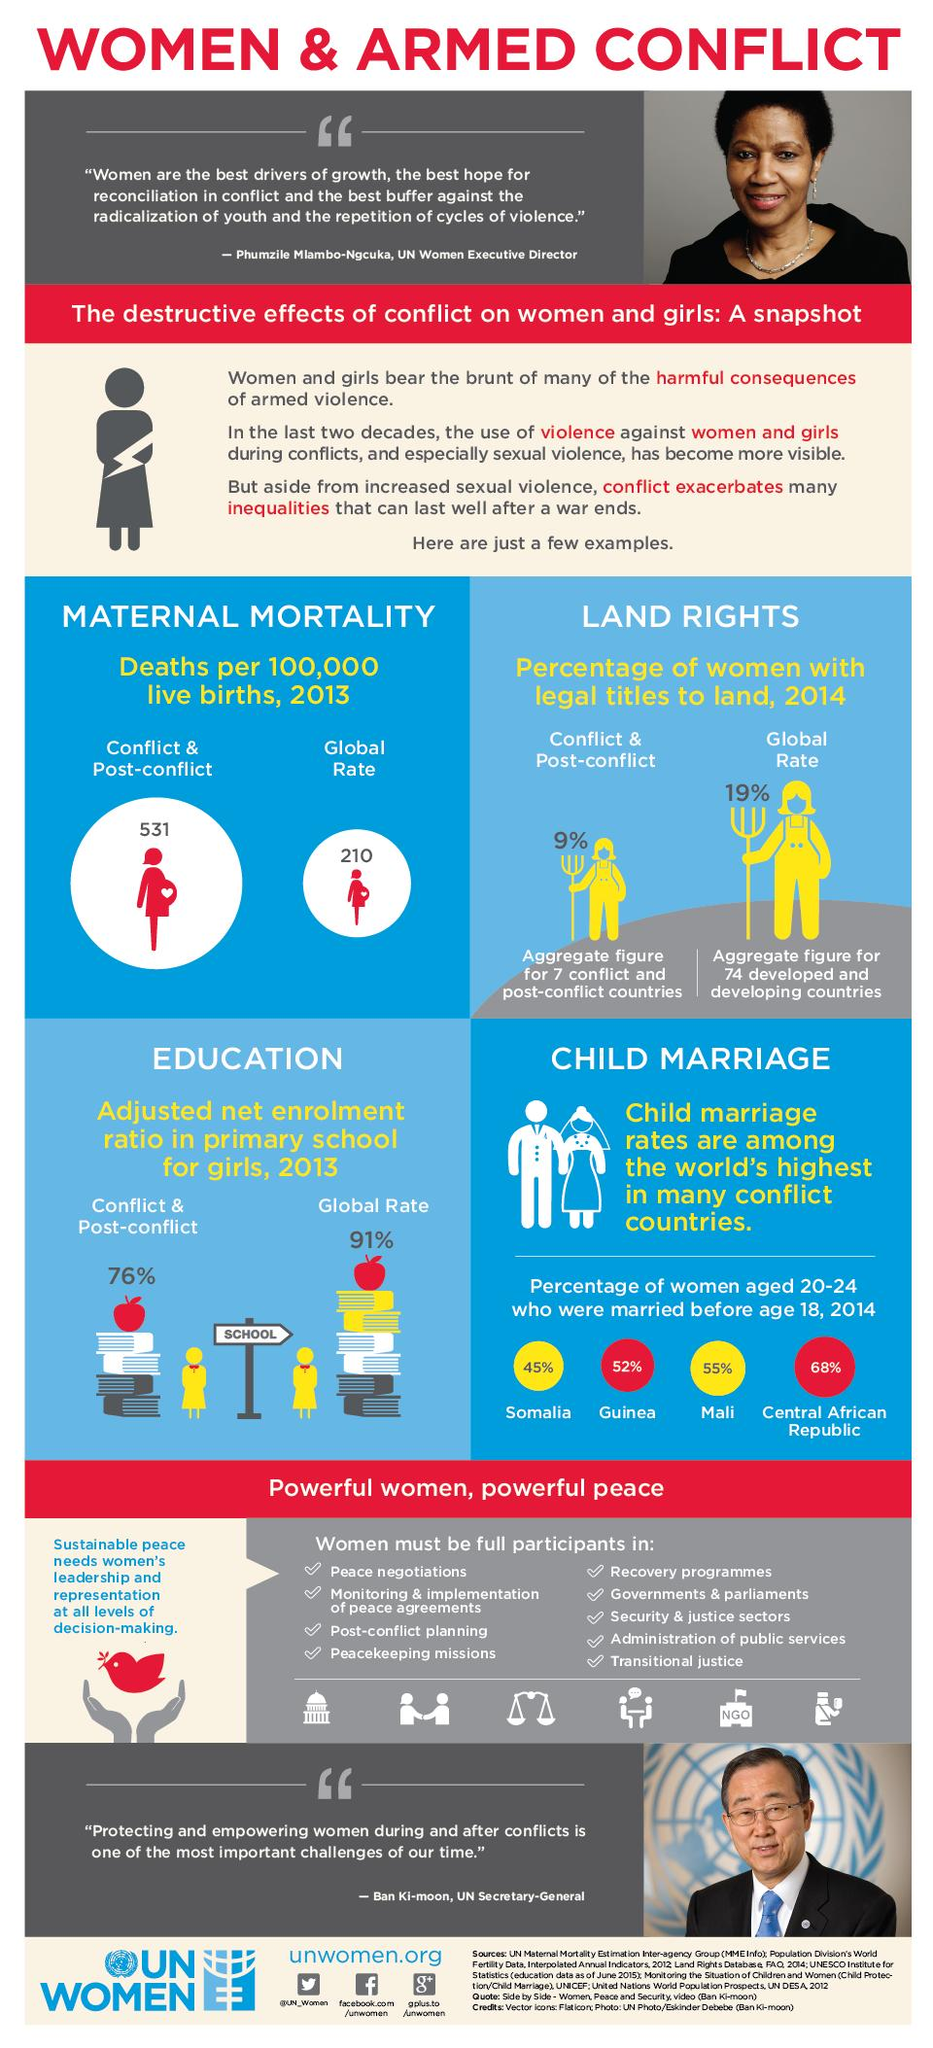Specify some key components in this picture. All women in Somalia and Mali who married before the age of 18 have married before 18. According to the provided information, 97% of women in Somalia and Guinea have married before the age of 18. 